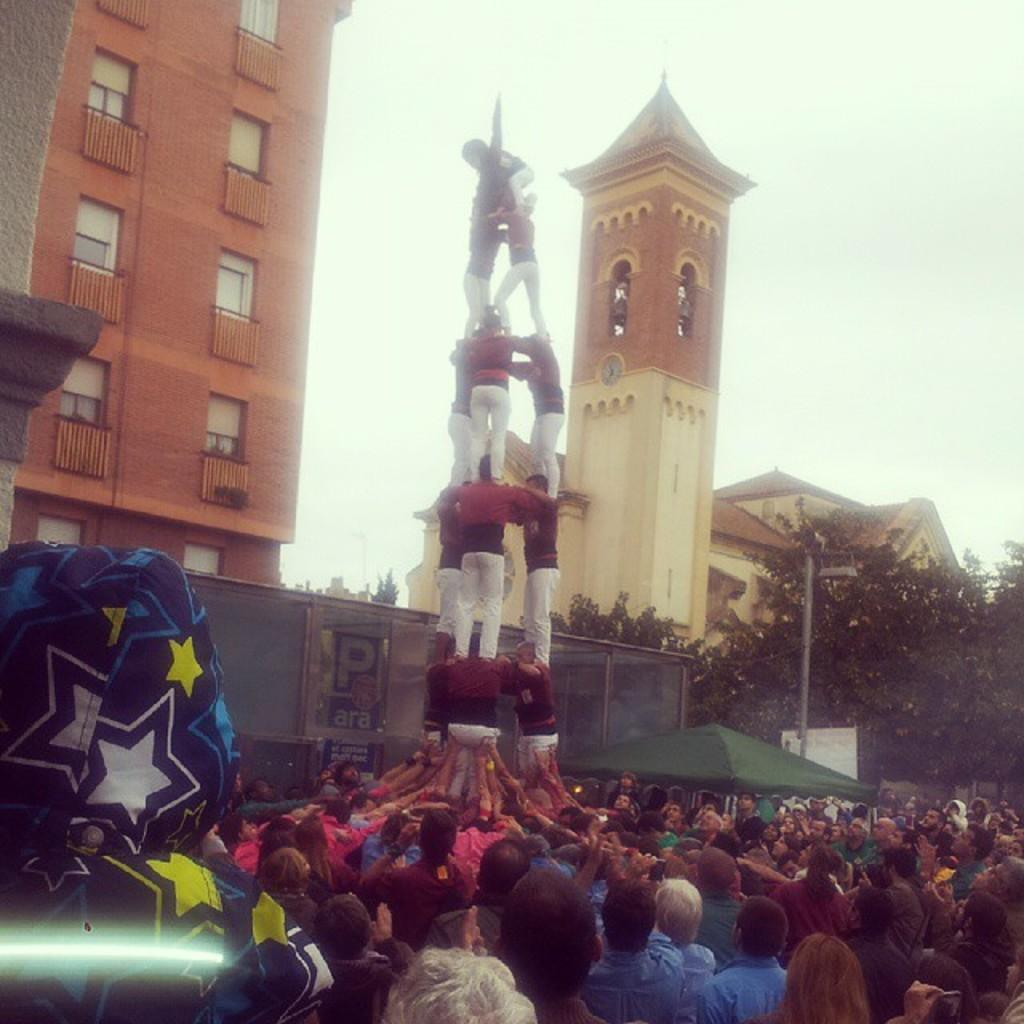What formation are the men in the image creating? The men are standing in the shape of a pyramid. What can be seen on the left side of the image? There is a building on the left side of the image. How many people are at the bottom of the pyramid? Many people are standing at the bottom of the pyramid, watching. What type of hill can be seen in the background of the image? There is no hill visible in the image. 